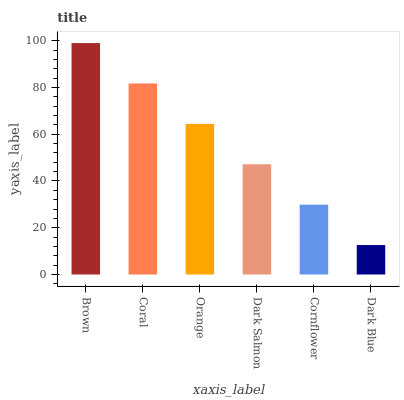Is Dark Blue the minimum?
Answer yes or no. Yes. Is Brown the maximum?
Answer yes or no. Yes. Is Coral the minimum?
Answer yes or no. No. Is Coral the maximum?
Answer yes or no. No. Is Brown greater than Coral?
Answer yes or no. Yes. Is Coral less than Brown?
Answer yes or no. Yes. Is Coral greater than Brown?
Answer yes or no. No. Is Brown less than Coral?
Answer yes or no. No. Is Orange the high median?
Answer yes or no. Yes. Is Dark Salmon the low median?
Answer yes or no. Yes. Is Dark Blue the high median?
Answer yes or no. No. Is Brown the low median?
Answer yes or no. No. 